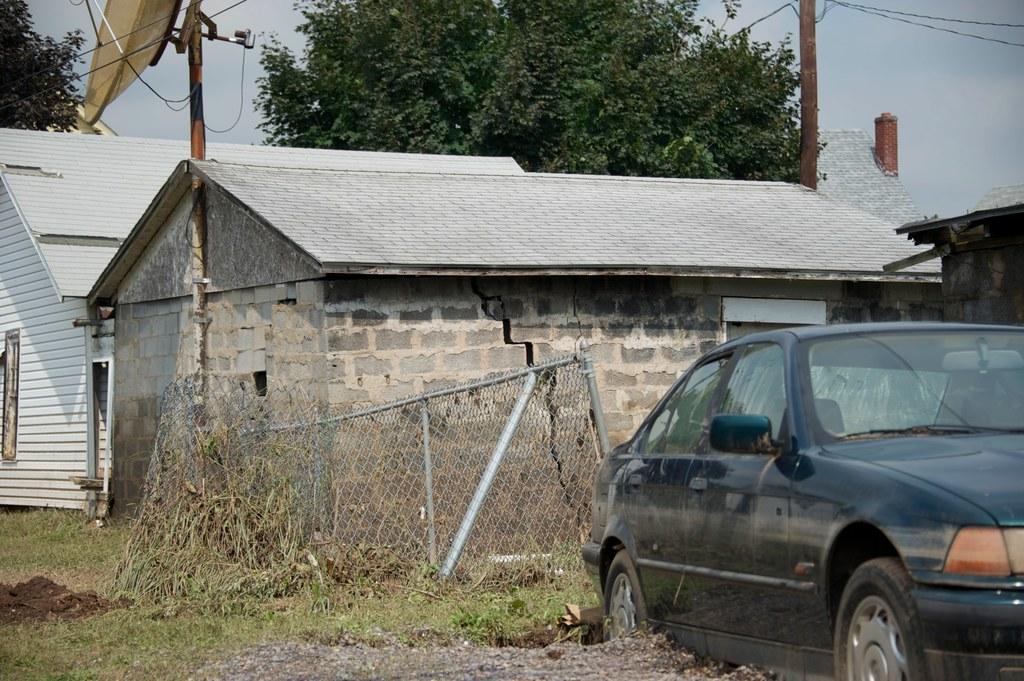Describe this image in one or two sentences. In the foreground of the picture there are plants, grass, car, railing and buildings. In the center of the picture there are trees, houses, current pole, antenna and cables. 